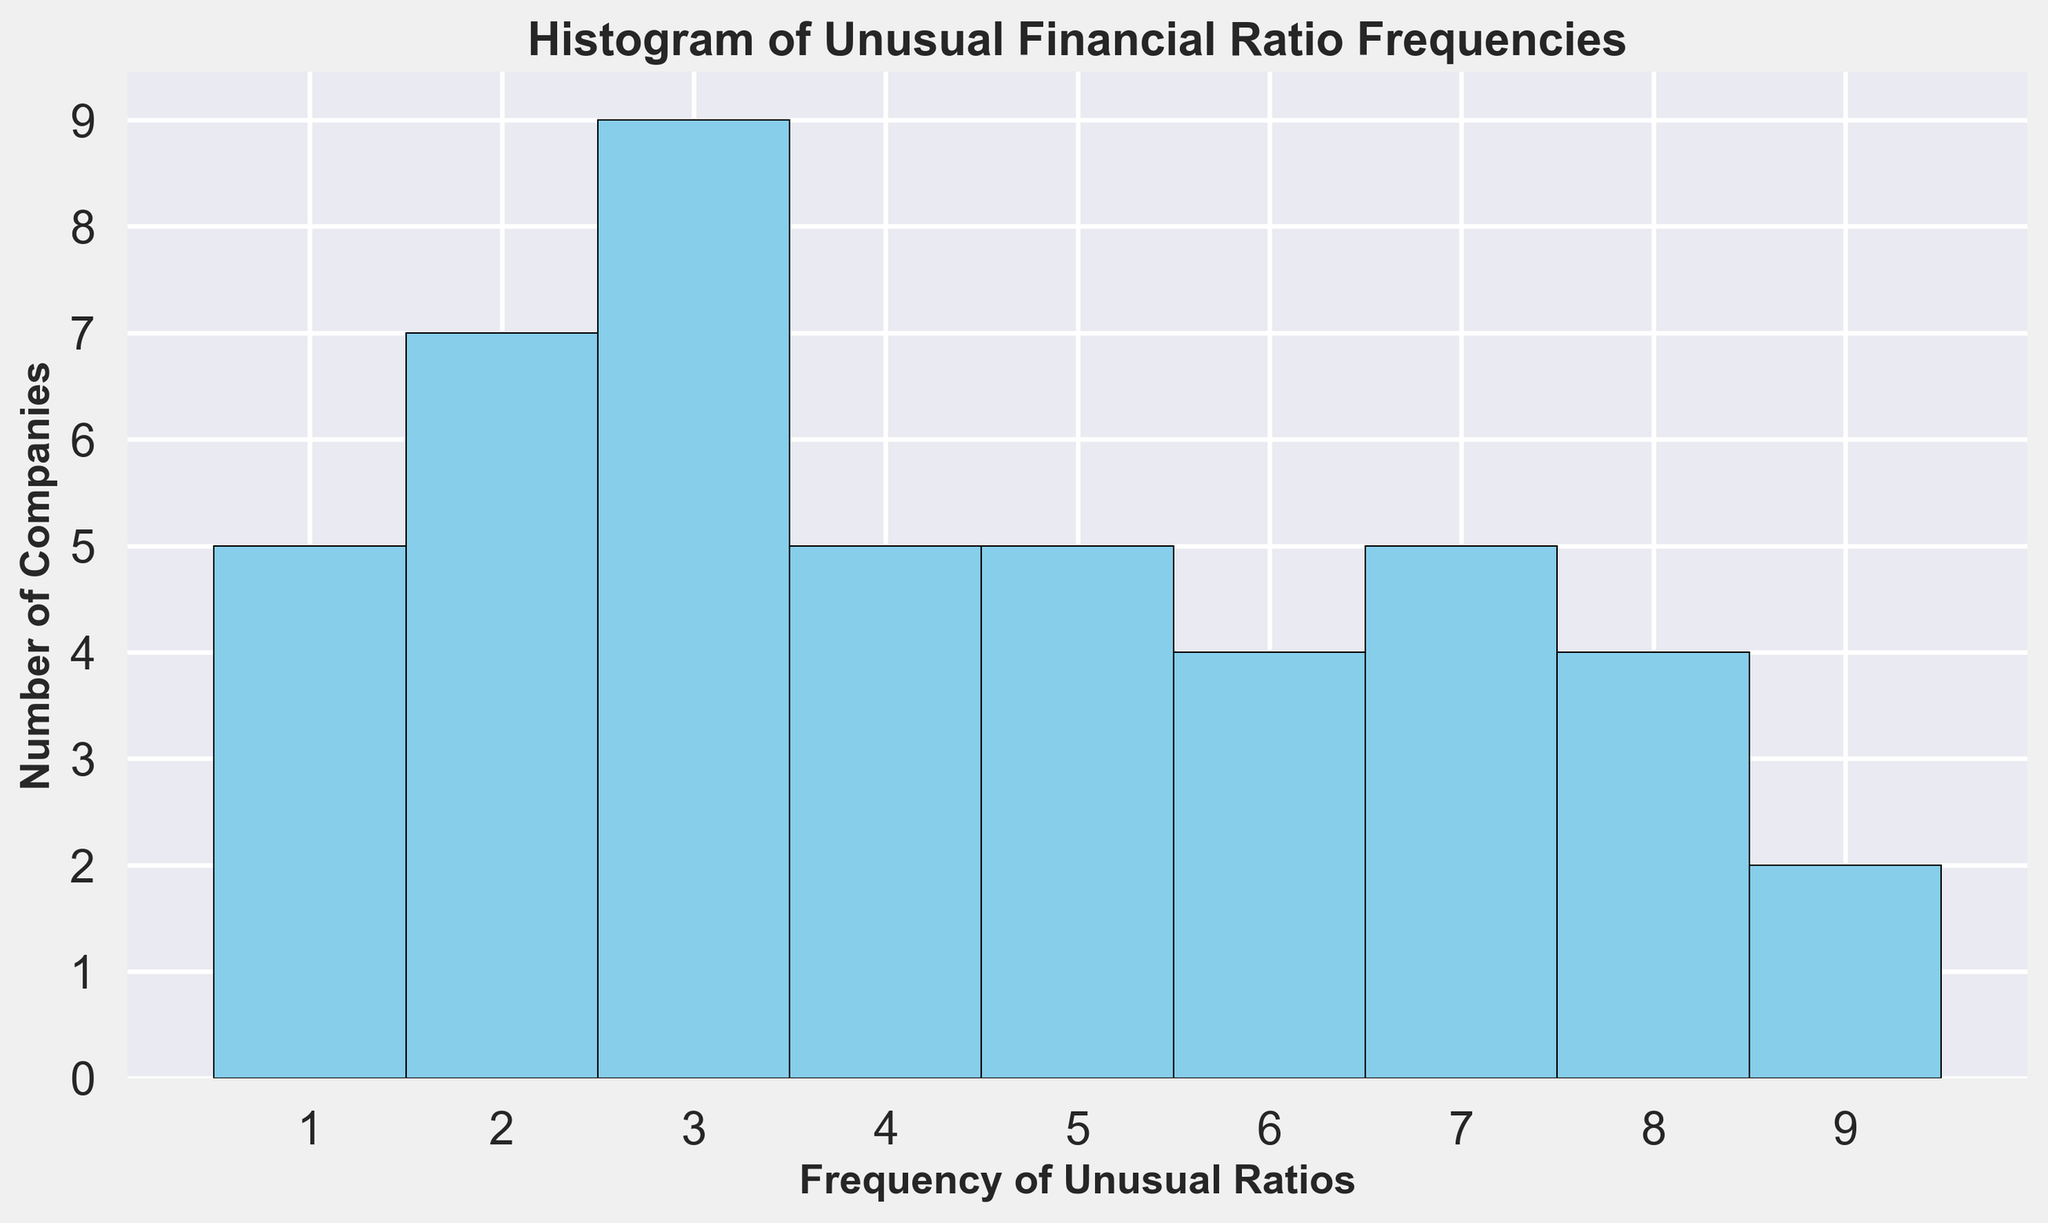What is the most frequent number of unusual financial ratios found across companies? The histogram shows the distribution of unusual financial ratio frequencies across companies. The tallest bar gives us the most frequent value. The highest bar is at the value 3, which means the most frequent number of unusual ratios is 3.
Answer: 3 How many companies have 6 unusual financial ratios? Look at the bar corresponding to the frequency of 6 on the x-axis, and check its height on the y-axis. The bar at 6 reaches up to 4, so there are 4 companies with 6 unusual financial ratios.
Answer: 4 How many fewer companies have 1 unusual ratio compared to those with 5 unusual ratios? We need to compare the heights of the bars at 1 and 5. The bar at 1 has a height of 4, and the bar at 5 has a height of 6. Subtract the numbers: 6 - 4 = 2.
Answer: 2 What is the total number of companies being analyzed in this histogram? Sum up the height of all bars to find the total number of companies. The heights of the bars at frequencies 1 to 9 are 4, 7, 6, 6, 6, 4, 5, 4, 3 respectively. Adding these up: 4 + 7 + 6 + 6 + 6 + 4 + 5 + 4 + 3 = 45.
Answer: 45 Which frequency of unusual ratios is reported by an equal number of companies as the frequency of 2 unusual ratios? We need to identify a bar that is of equal height to the bar at 2. The bar at 2 is at a height of 7. The bar at 5 is also at a height of 7.
Answer: 5 Which range of unusual ratio frequencies has the least number of companies? Look for the shortest bar in the histogram. The bar at 9 has the smallest height of 3, indicating the least number of companies.
Answer: 9 Calculate the average number of unusual financial ratios per company. Sum the products of each frequency and the count of companies with that frequency, and then divide by the total number of companies. (1×4) + (2×7) + (3×6) + (4×6) + (5×6) + (6×4) + (7×5) + (8×4) + (9×3) = 4 + 14 + 18 + 24 + 30 + 24 + 35 + 32 + 27 = 208. Divide by the total number of companies (45): 208/45 = 4.62.
Answer: 4.62 What proportion of companies have an unusual ratio frequency of 8 or higher? Count the number of companies with frequencies of 8 and 9, then divide by the total number of companies. Companies with 8 = 4, companies with 9 = 3. Total = 4 + 3 = 7. Proportion = 7/45.
Answer: 7/45 What is the difference in the number of companies between those with unusual ratio frequencies of 3 and 4? Identify the heights of the bars at 3 and 4. Frequency of 3 has a height of 6 and frequency of 4 also has a height of 6. The difference is 6 - 6 = 0.
Answer: 0 